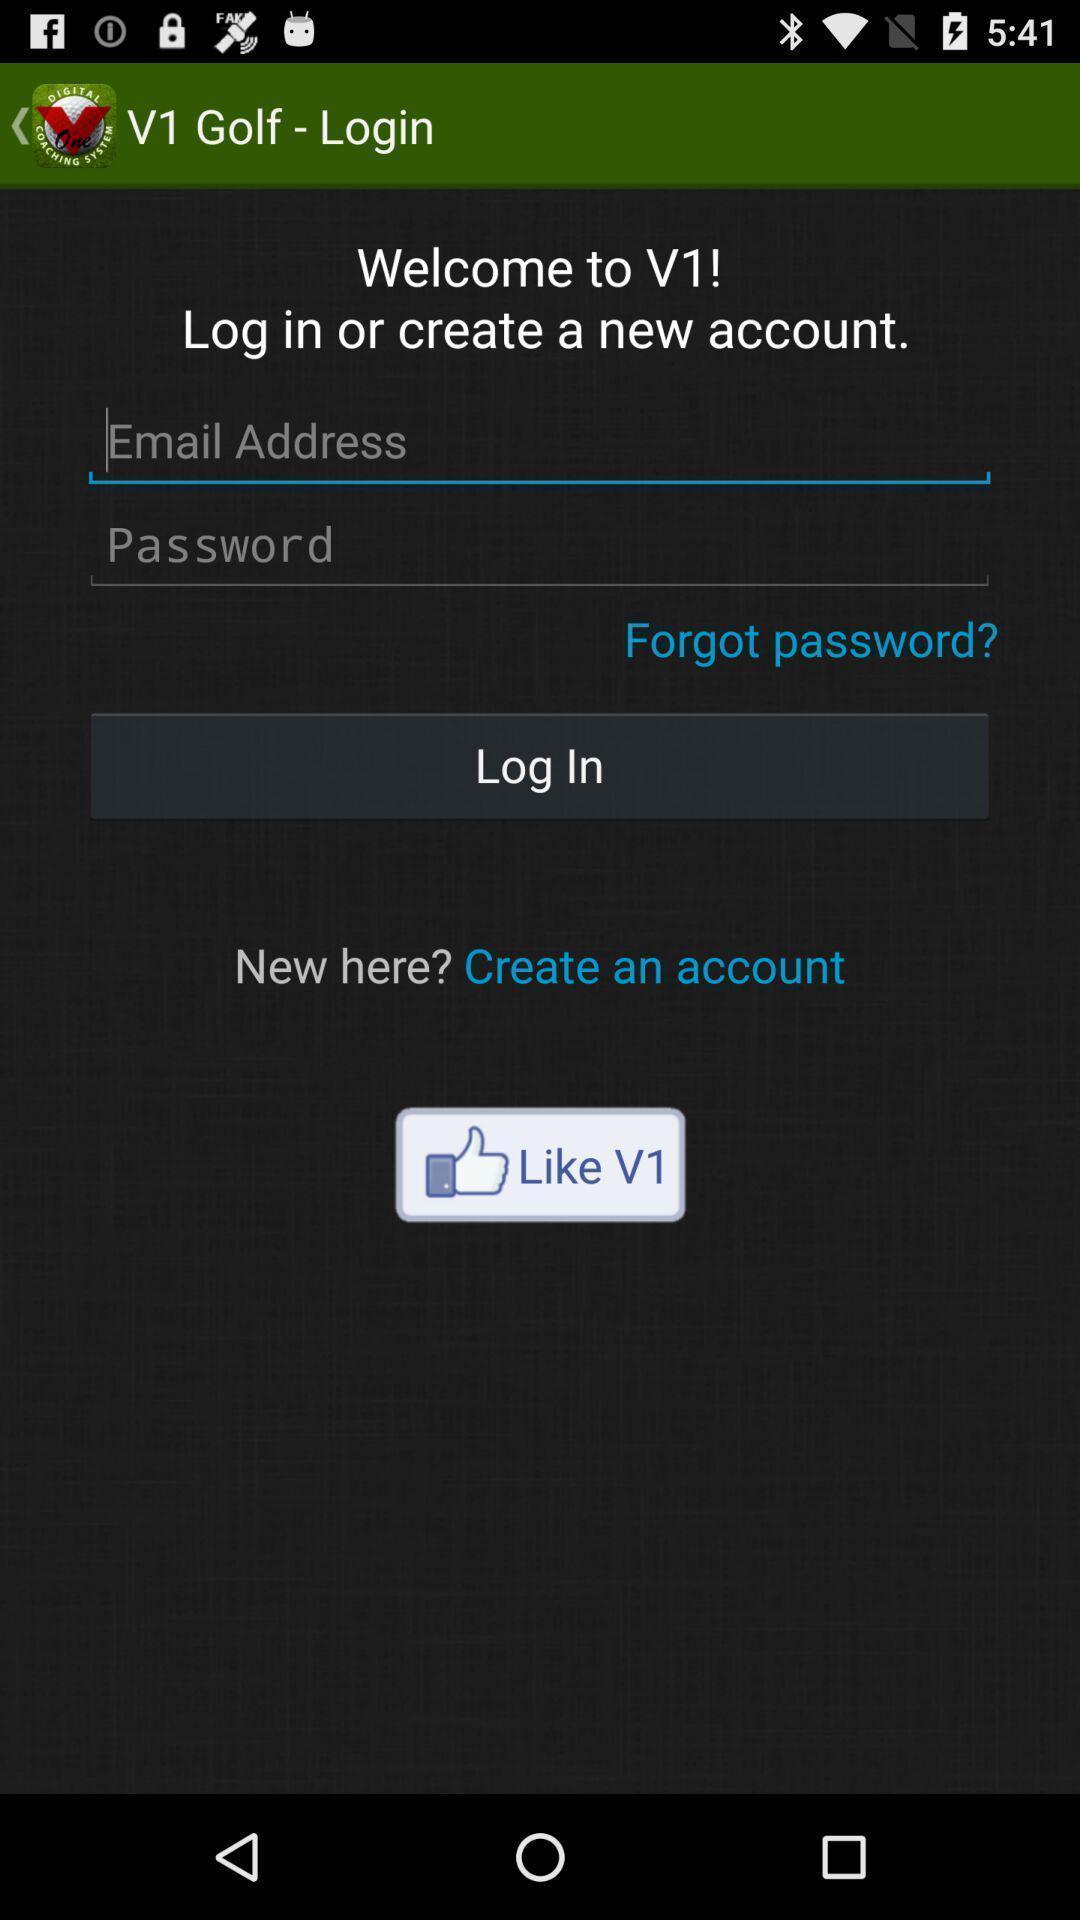Describe this image in words. Page showing login page. 